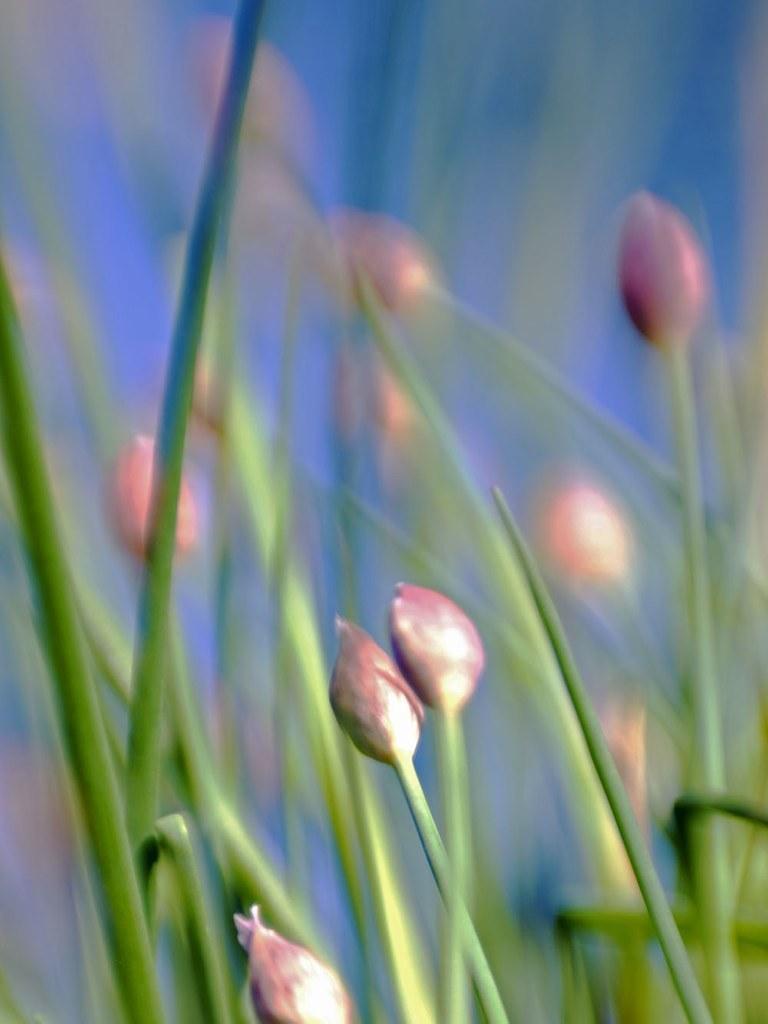How would you summarize this image in a sentence or two? In this image in the foreground there are some plants and flowers, and in the background there is sky. 